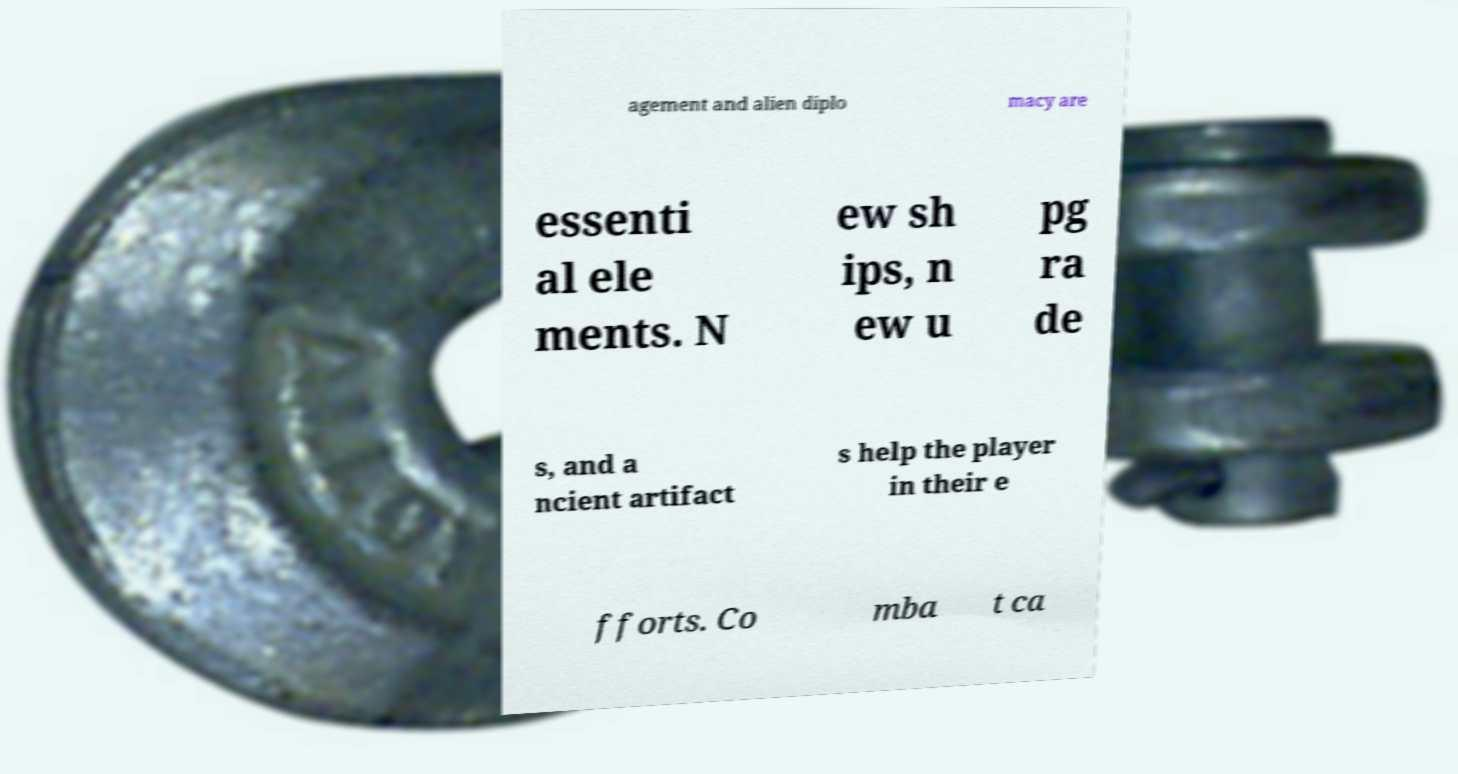Please read and relay the text visible in this image. What does it say? agement and alien diplo macy are essenti al ele ments. N ew sh ips, n ew u pg ra de s, and a ncient artifact s help the player in their e fforts. Co mba t ca 